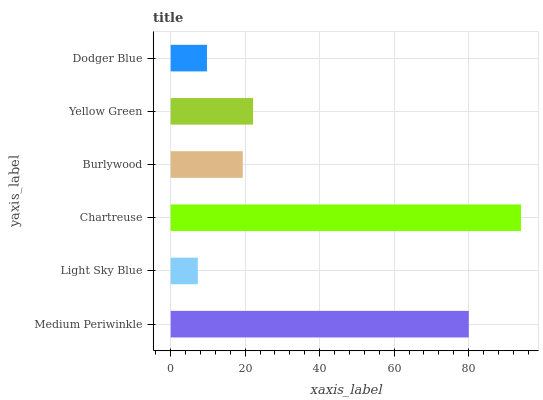Is Light Sky Blue the minimum?
Answer yes or no. Yes. Is Chartreuse the maximum?
Answer yes or no. Yes. Is Chartreuse the minimum?
Answer yes or no. No. Is Light Sky Blue the maximum?
Answer yes or no. No. Is Chartreuse greater than Light Sky Blue?
Answer yes or no. Yes. Is Light Sky Blue less than Chartreuse?
Answer yes or no. Yes. Is Light Sky Blue greater than Chartreuse?
Answer yes or no. No. Is Chartreuse less than Light Sky Blue?
Answer yes or no. No. Is Yellow Green the high median?
Answer yes or no. Yes. Is Burlywood the low median?
Answer yes or no. Yes. Is Chartreuse the high median?
Answer yes or no. No. Is Medium Periwinkle the low median?
Answer yes or no. No. 